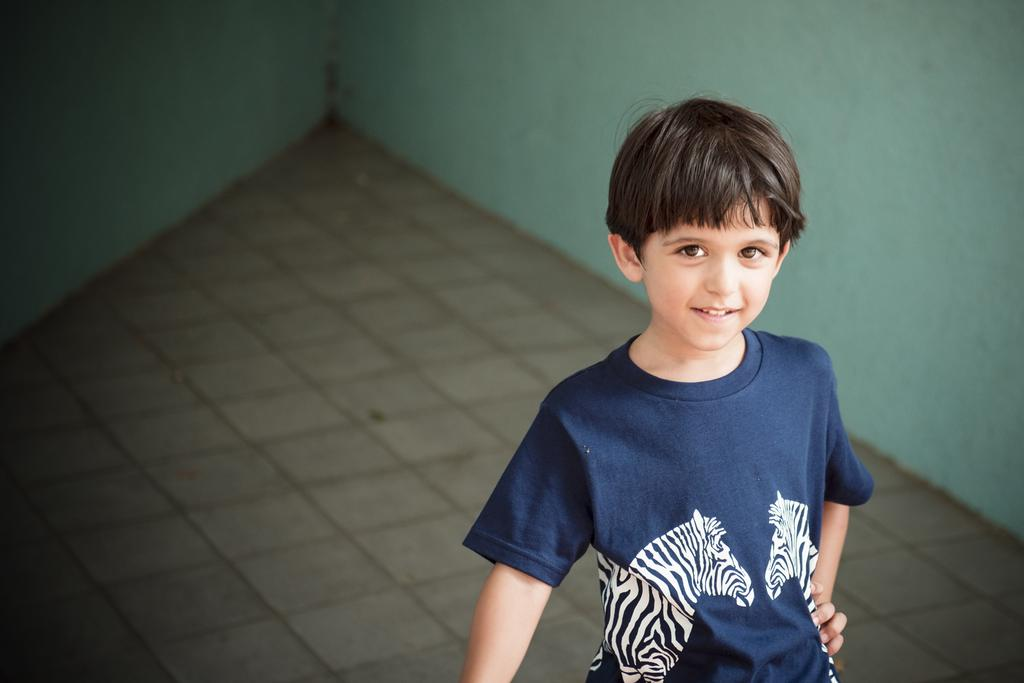What is the main subject of the image? The main subject of the image is a boy. What is the boy wearing in the image? The boy is wearing a t-shirt in the image. What is the boy's facial expression in the image? The boy is smiling in the image. What can be seen in the background of the image? There is a surface and a wall visible in the background of the image. What type of beef is the boy holding in the image? There is no beef present in the image; the boy is not holding anything. Is the boy using a quill to write on the wall in the image? There is no quill or writing on the wall in the image; the boy is simply smiling and wearing a t-shirt. 